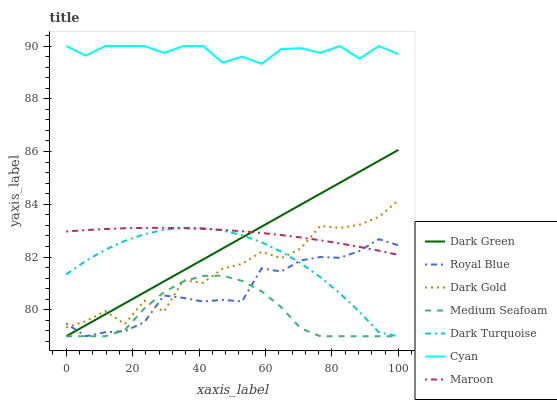Does Medium Seafoam have the minimum area under the curve?
Answer yes or no. Yes. Does Cyan have the maximum area under the curve?
Answer yes or no. Yes. Does Dark Turquoise have the minimum area under the curve?
Answer yes or no. No. Does Dark Turquoise have the maximum area under the curve?
Answer yes or no. No. Is Dark Green the smoothest?
Answer yes or no. Yes. Is Dark Gold the roughest?
Answer yes or no. Yes. Is Dark Turquoise the smoothest?
Answer yes or no. No. Is Dark Turquoise the roughest?
Answer yes or no. No. Does Dark Turquoise have the lowest value?
Answer yes or no. Yes. Does Maroon have the lowest value?
Answer yes or no. No. Does Cyan have the highest value?
Answer yes or no. Yes. Does Dark Turquoise have the highest value?
Answer yes or no. No. Is Dark Gold less than Cyan?
Answer yes or no. Yes. Is Cyan greater than Royal Blue?
Answer yes or no. Yes. Does Maroon intersect Dark Green?
Answer yes or no. Yes. Is Maroon less than Dark Green?
Answer yes or no. No. Is Maroon greater than Dark Green?
Answer yes or no. No. Does Dark Gold intersect Cyan?
Answer yes or no. No. 